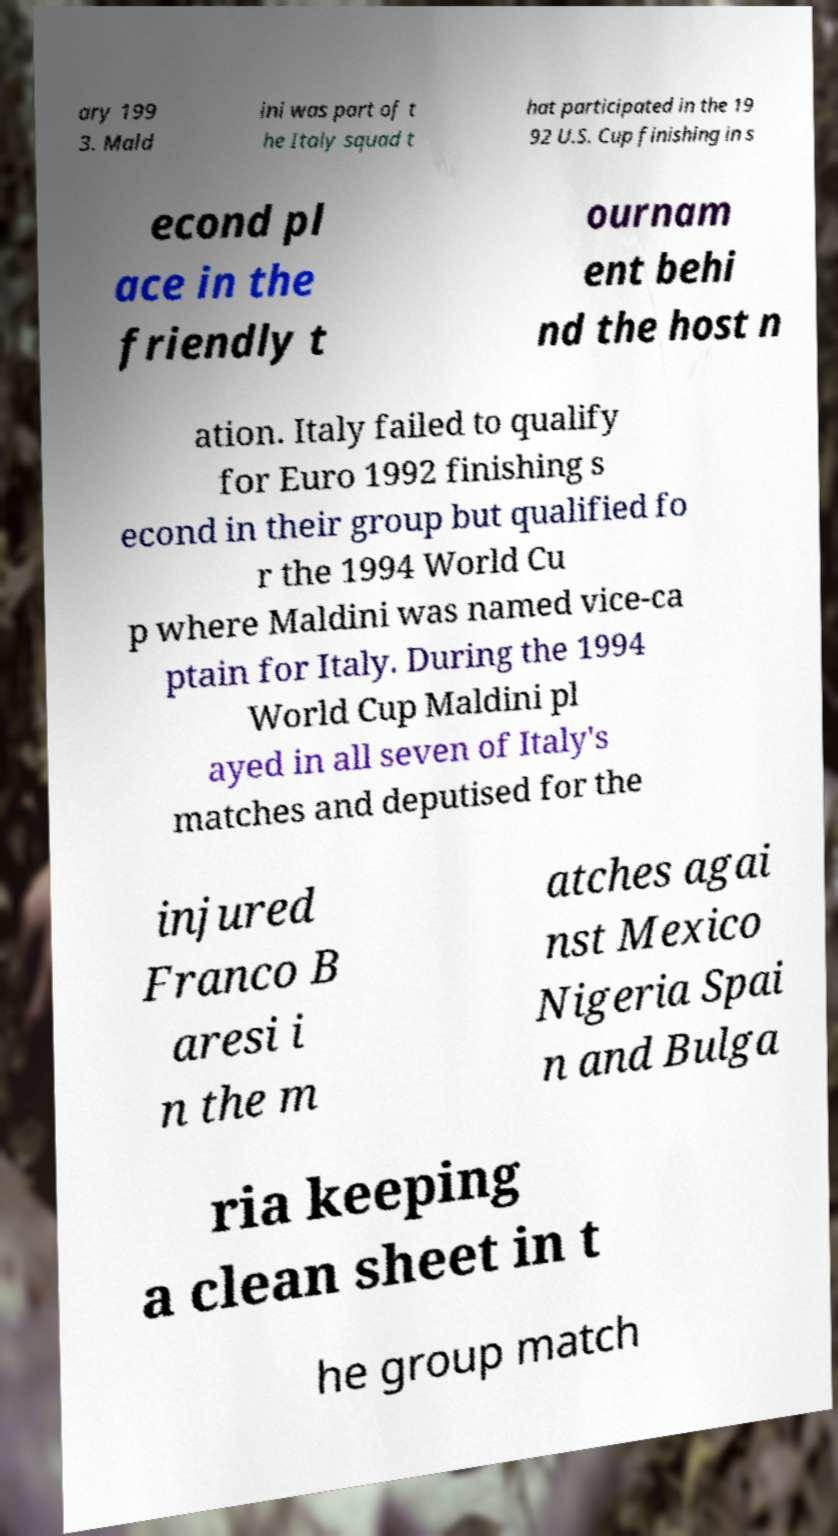Please read and relay the text visible in this image. What does it say? ary 199 3. Mald ini was part of t he Italy squad t hat participated in the 19 92 U.S. Cup finishing in s econd pl ace in the friendly t ournam ent behi nd the host n ation. Italy failed to qualify for Euro 1992 finishing s econd in their group but qualified fo r the 1994 World Cu p where Maldini was named vice-ca ptain for Italy. During the 1994 World Cup Maldini pl ayed in all seven of Italy's matches and deputised for the injured Franco B aresi i n the m atches agai nst Mexico Nigeria Spai n and Bulga ria keeping a clean sheet in t he group match 